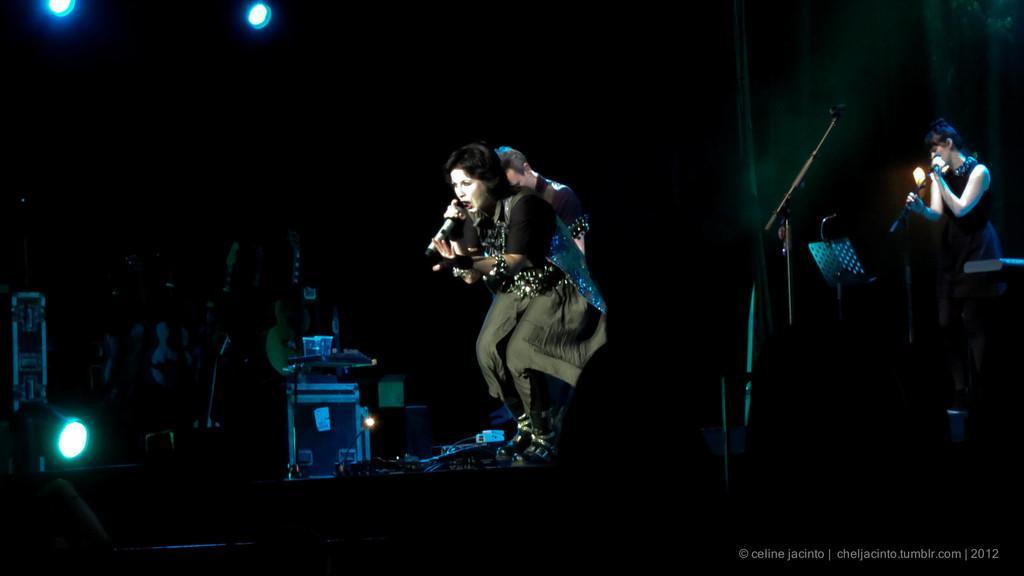Please provide a concise description of this image. In this image I can see group of people. The person in front standing and holding a microphone and singing, and the person is wearing black and gray color dress. The background is in black color. 